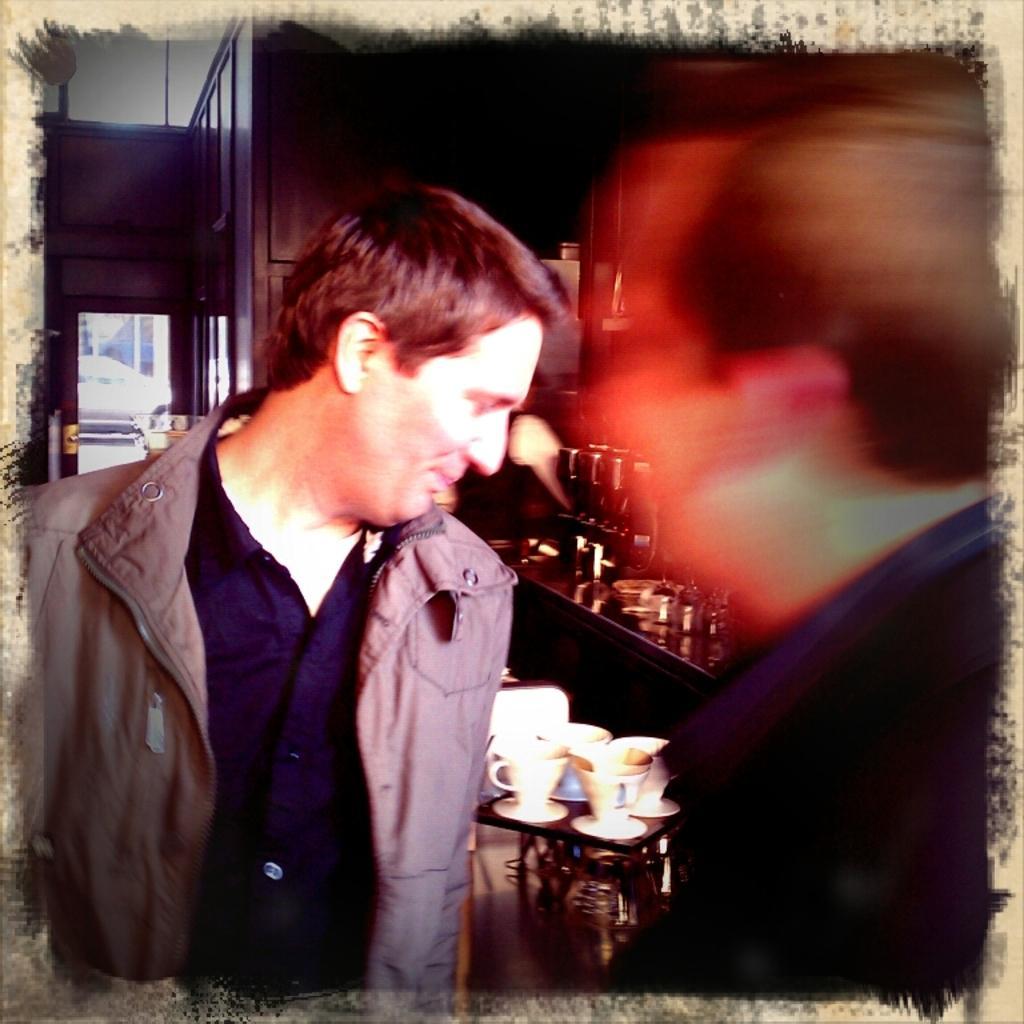In one or two sentences, can you explain what this image depicts? In this image I can see a person wearing brown colored jacket is standing and I can see another person who is blurry. I can see few cups and few other objects. In the background I can see a door through which I can see a car. 